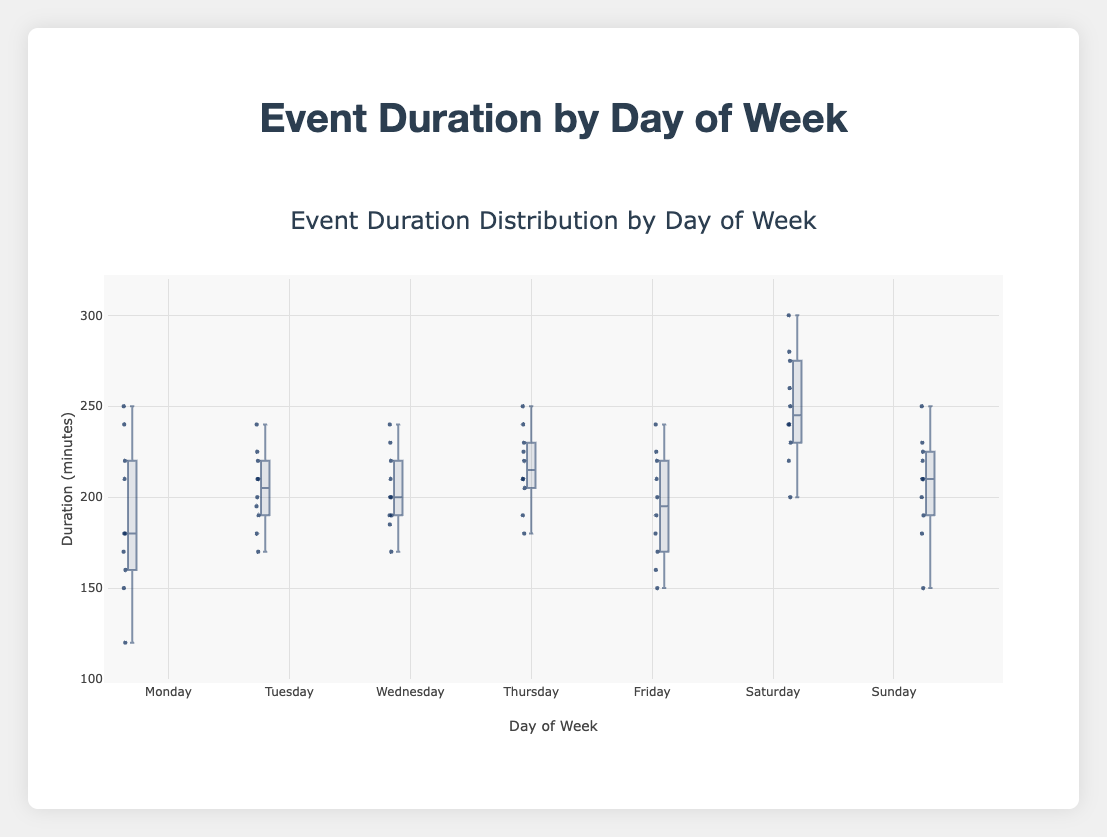Which day has the median event duration closest to 220 minutes? To find the median for each day's event durations by looking at the middle line of each box, we see that the median for Thursday is closest to 220 minutes.
Answer: Thursday What is the range of event durations on Monday? The range of event durations can be found by subtracting the minimum value from the maximum value within the box plot for Monday. This range spans from 120 to 250 minutes, resulting in a range of 130 minutes.
Answer: 130 minutes Which two days have the most similar medians? By comparing the median lines of all box plots, Monday and Friday have medians close to 180 minutes, making them the most similar.
Answer: Monday and Friday What is the interquartile range (IQR) for Saturday? The IQR is calculated by subtracting the value at the first quartile (bottom of the box) from the value at the third quartile (top of the box). For Saturday, this is 275 - 230 = 45 minutes.
Answer: 45 minutes On which day is the most consistent event duration observed? The consistency in event duration is reflected by the smallest interquartile range (IQR). Looking closely, Wednesday has the smallest IQR, indicating consistent event durations.
Answer: Wednesday Is there a day where the minimum event duration is higher than any other day’s minimum? Yes, Saturday's minimum event duration is 200 minutes, which is higher than the minimum durations on all other days.
Answer: Saturday Which day shows the highest variability in event duration? Variability can be assessed by looking at the total range (distance between the lowest and highest points). Saturday shows the highest variability with a range from 200 to 300 minutes.
Answer: Saturday Which day has a maximum event duration similar to that on Thursday but higher than other days? Both Thursday and Saturday have maximum event durations close to 250 minutes, but Saturday’s maximum is higher, at 300 minutes.
Answer: Saturday Which days have their third quartile higher than 250 minutes? Third quartiles for Thursday, Saturday, and Sunday are above 250 minutes when examining the box plots.
Answer: Thursday, Saturday, Sunday During which day do events have a bimodal distribution? By checking the distribution of data points at different segments, Friday shows a possible bimodal pattern with clusters around 160-170 minutes and another near 210 minutes.
Answer: Friday 